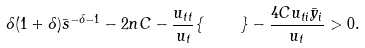<formula> <loc_0><loc_0><loc_500><loc_500>\delta ( 1 + \delta ) \bar { s } ^ { - \delta - 1 } - 2 n C - \frac { u _ { t t } } { u _ { t } } \{ \quad \} - \frac { 4 C u _ { t i } \bar { y } _ { i } } { u _ { t } } > 0 .</formula> 